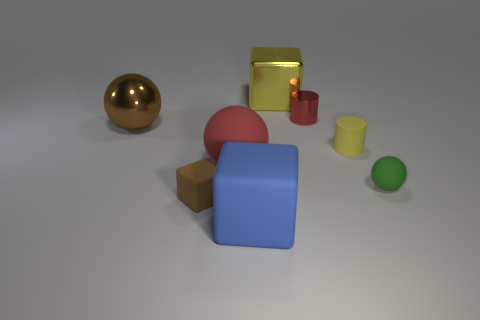Subtract all small cubes. How many cubes are left? 2 Subtract all yellow cylinders. How many cylinders are left? 1 Add 2 tiny cyan matte balls. How many objects exist? 10 Subtract all balls. How many objects are left? 5 Subtract 1 cubes. How many cubes are left? 2 Subtract all yellow cylinders. Subtract all green cubes. How many cylinders are left? 1 Subtract all yellow metal blocks. Subtract all big red matte spheres. How many objects are left? 6 Add 5 big red matte spheres. How many big red matte spheres are left? 6 Add 7 metal balls. How many metal balls exist? 8 Subtract 1 blue cubes. How many objects are left? 7 